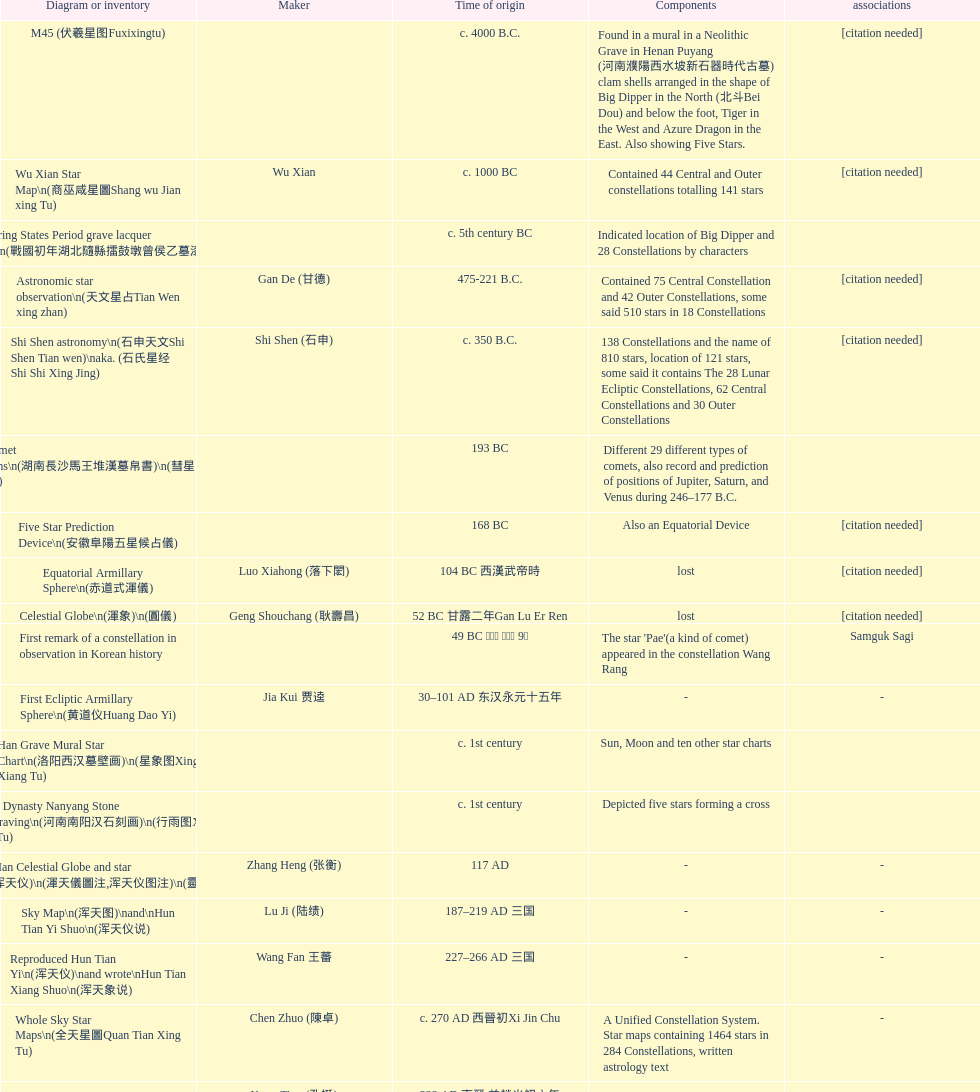Did xu guang ci or su song create the five star charts in 1094 ad? Su Song 蘇頌. 